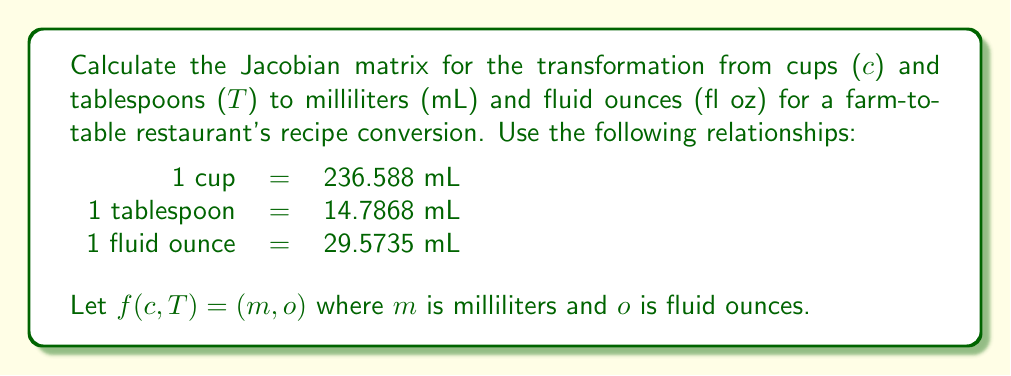Show me your answer to this math problem. To compute the Jacobian matrix, we need to find the partial derivatives of each output variable with respect to each input variable.

Step 1: Express $m$ and $o$ in terms of $c$ and $T$:
$$m = 236.588c + 14.7868T$$
$$o = \frac{236.588c + 14.7868T}{29.5735}$$

Step 2: Calculate the partial derivatives:

$\frac{\partial m}{\partial c} = 236.588$

$\frac{\partial m}{\partial T} = 14.7868$

$\frac{\partial o}{\partial c} = \frac{236.588}{29.5735} = 8$

$\frac{\partial o}{\partial T} = \frac{14.7868}{29.5735} = 0.5$

Step 3: Arrange the partial derivatives in the Jacobian matrix:

$$J = \begin{bmatrix}
\frac{\partial m}{\partial c} & \frac{\partial m}{\partial T} \\
\frac{\partial o}{\partial c} & \frac{\partial o}{\partial T}
\end{bmatrix} = \begin{bmatrix}
236.588 & 14.7868 \\
8 & 0.5
\end{bmatrix}$$
Answer: $$J = \begin{bmatrix}
236.588 & 14.7868 \\
8 & 0.5
\end{bmatrix}$$ 